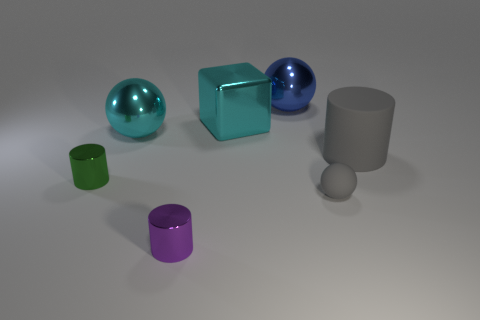Add 2 gray matte cylinders. How many objects exist? 9 Subtract all blocks. How many objects are left? 6 Subtract 0 yellow blocks. How many objects are left? 7 Subtract all small green cylinders. Subtract all big gray spheres. How many objects are left? 6 Add 6 gray balls. How many gray balls are left? 7 Add 4 rubber balls. How many rubber balls exist? 5 